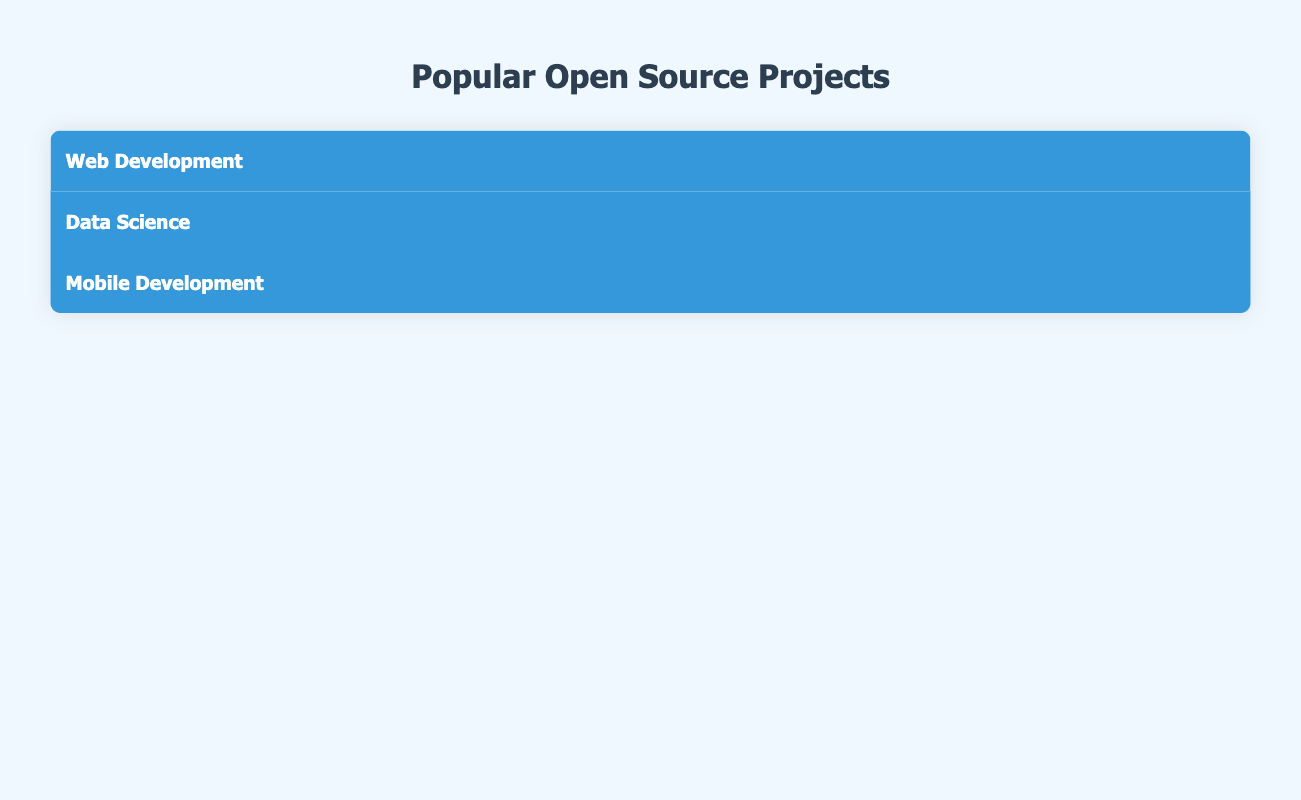What is the highest number of stars among the JavaScript projects? The JavaScript projects listed are React with 202,000 stars and Vue.js with 206,000 stars. Comparing these two, Vue.js has the highest number of stars.
Answer: 206000 How many Python projects are listed under Web Development? There are two Python projects listed under Web Development: Django and Flask.
Answer: 2 Is Alamofire the only Swift project mentioned? Alamofire is the only project mentioned under Swift without any other projects listed alongside it. Thus, the statement is true.
Answer: Yes What is the average number of stars for the Data Science projects listed? The Data Science projects and their stars are Pandas with 35,300 stars, Scikit-learn with 57,200 stars, and ggplot2 with 55,800 stars. The average is calculated as (35300 + 57200 + 55800) / 3 = 49400.
Answer: 49400 Which category has the most projects listed? By counting, Web Development has four projects, Data Science has three, and Mobile Development has two. Therefore, Web Development has the most projects listed.
Answer: Web Development What is the combined number of stars for all Python projects listed? The Python projects listed are Django with 95,600 stars and Flask with 61,700 stars. Summing these gives a total of 95,600 + 61,700 = 157,300 stars for the Python projects.
Answer: 157300 Does any Kotlin project have more than 30,000 stars? The only Kotlin project listed is Kotlin Coroutines, which has 20,100 stars, therefore it does not exceed 30,000 stars.
Answer: No Which project has the least number of stars in the table? The projects listed are Alamofire with 37,700 stars, Kotlin Coroutines with 20,100 stars, Pandas with 35,300 stars, Scikit-learn with 57,200 stars, Django with 95,600 stars, Flask with 61,700 stars, React with 202,000 stars, and Vue.js with 206,000 stars. The project with the least stars is Kotlin Coroutines.
Answer: Kotlin Coroutines 